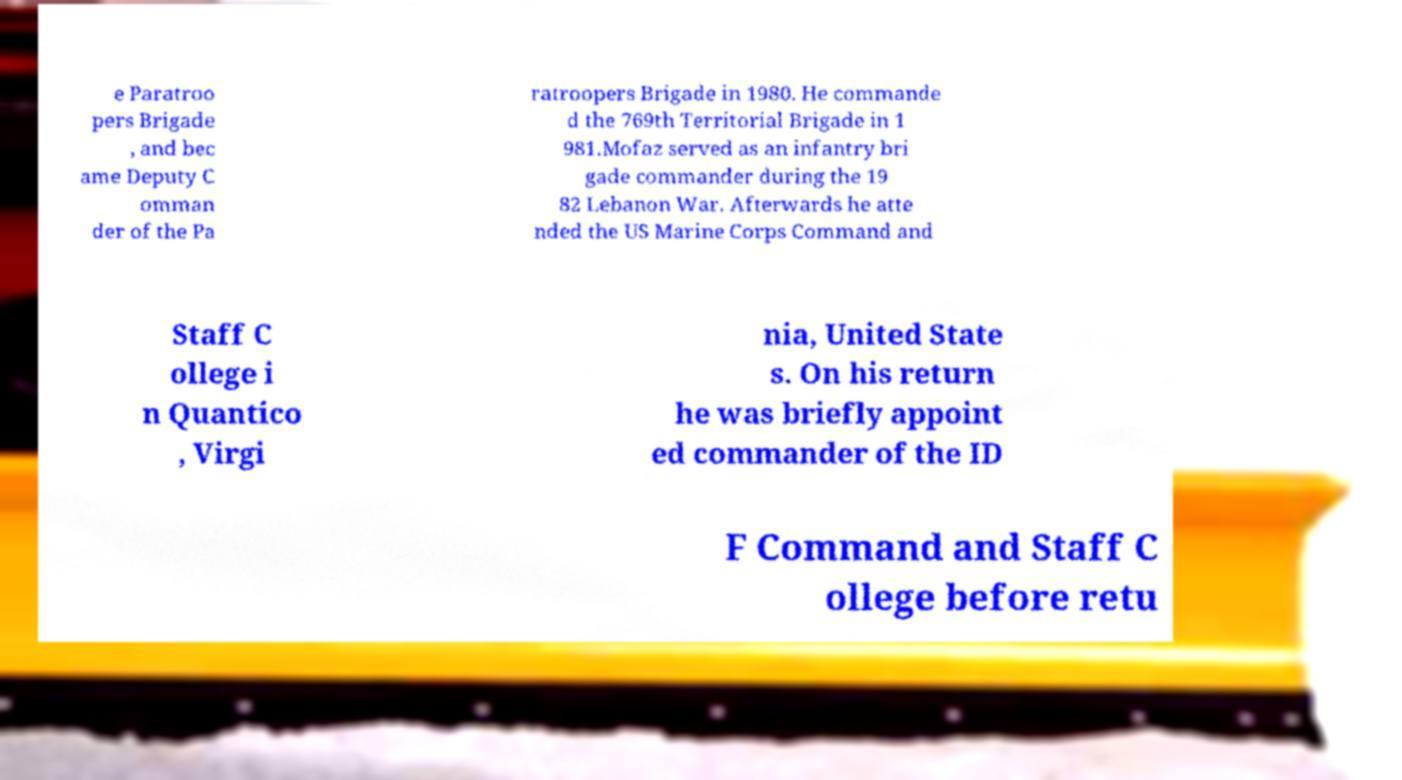What messages or text are displayed in this image? I need them in a readable, typed format. e Paratroo pers Brigade , and bec ame Deputy C omman der of the Pa ratroopers Brigade in 1980. He commande d the 769th Territorial Brigade in 1 981.Mofaz served as an infantry bri gade commander during the 19 82 Lebanon War. Afterwards he atte nded the US Marine Corps Command and Staff C ollege i n Quantico , Virgi nia, United State s. On his return he was briefly appoint ed commander of the ID F Command and Staff C ollege before retu 